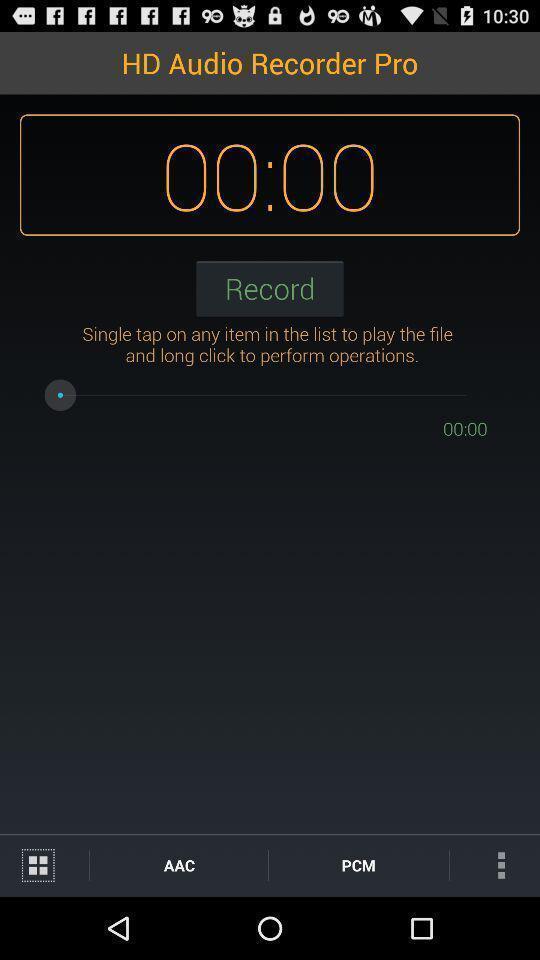Summarize the information in this screenshot. Page showing audio recorder app. 